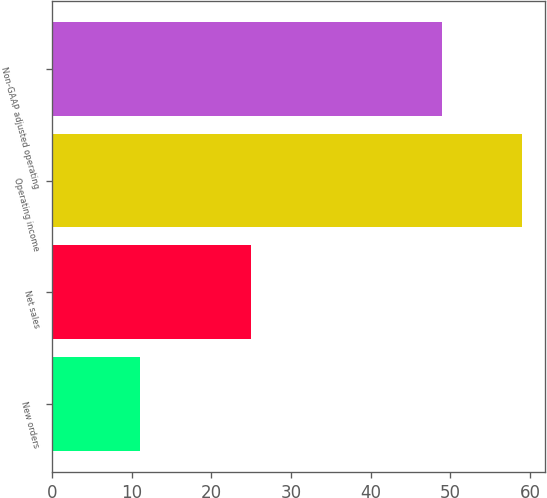<chart> <loc_0><loc_0><loc_500><loc_500><bar_chart><fcel>New orders<fcel>Net sales<fcel>Operating income<fcel>Non-GAAP adjusted operating<nl><fcel>11<fcel>25<fcel>59<fcel>49<nl></chart> 